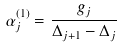Convert formula to latex. <formula><loc_0><loc_0><loc_500><loc_500>\alpha _ { j } ^ { ( 1 ) } = \frac { g _ { j } } { \Delta _ { j + 1 } - \Delta _ { j } }</formula> 